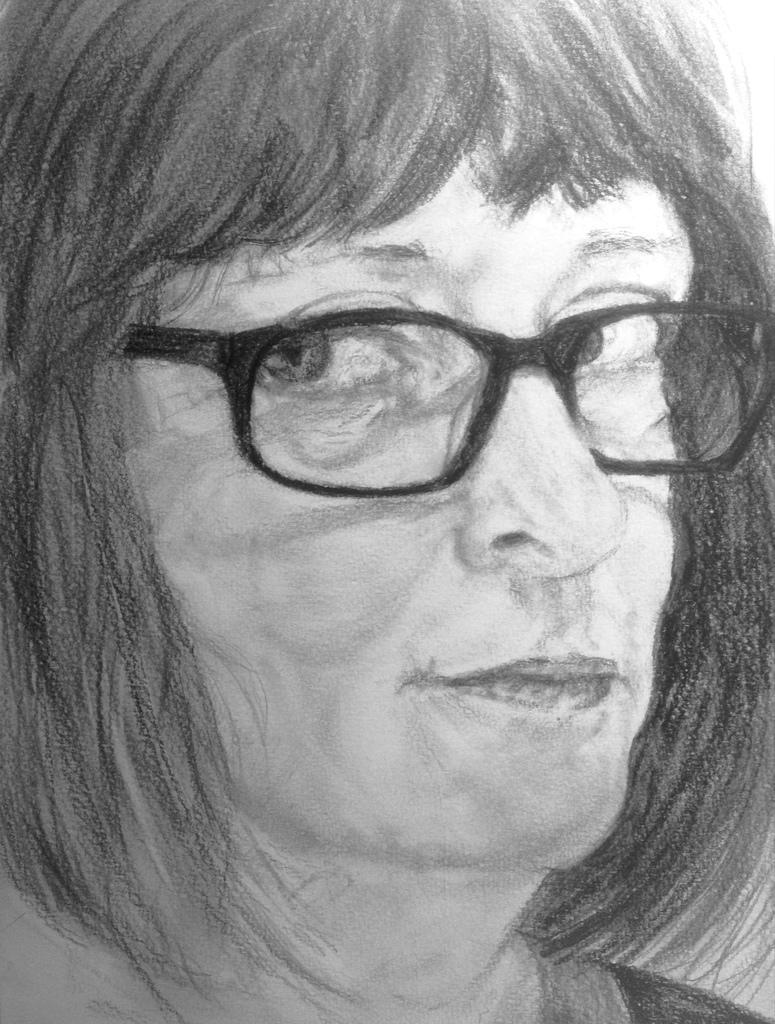What type of drawing is depicted in the image? The image is a sketch. Can you describe the main subject of the sketch? There is a lady in the sketch. What accessory is the lady wearing in the sketch? The lady is wearing spectacles. What verse is the lady reciting in the sketch? There is no verse or indication of recitation in the sketch; it only shows a lady wearing spectacles. 